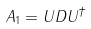Convert formula to latex. <formula><loc_0><loc_0><loc_500><loc_500>A _ { 1 } = U D U ^ { \dagger }</formula> 